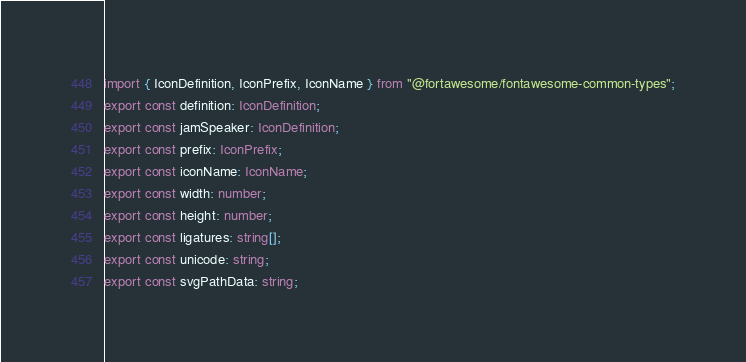<code> <loc_0><loc_0><loc_500><loc_500><_TypeScript_>import { IconDefinition, IconPrefix, IconName } from "@fortawesome/fontawesome-common-types";
export const definition: IconDefinition;
export const jamSpeaker: IconDefinition;
export const prefix: IconPrefix;
export const iconName: IconName;
export const width: number;
export const height: number;
export const ligatures: string[];
export const unicode: string;
export const svgPathData: string;</code> 